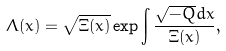Convert formula to latex. <formula><loc_0><loc_0><loc_500><loc_500>\Lambda ( x ) = \sqrt { \Xi ( x ) } \exp \int \frac { \sqrt { - Q } d x } { \Xi ( x ) } ,</formula> 